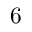Convert formula to latex. <formula><loc_0><loc_0><loc_500><loc_500>6</formula> 